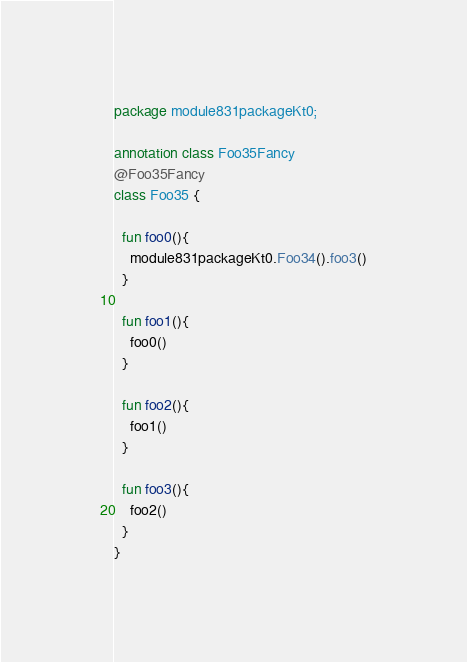Convert code to text. <code><loc_0><loc_0><loc_500><loc_500><_Kotlin_>package module831packageKt0;

annotation class Foo35Fancy
@Foo35Fancy
class Foo35 {

  fun foo0(){
    module831packageKt0.Foo34().foo3()
  }

  fun foo1(){
    foo0()
  }

  fun foo2(){
    foo1()
  }

  fun foo3(){
    foo2()
  }
}</code> 